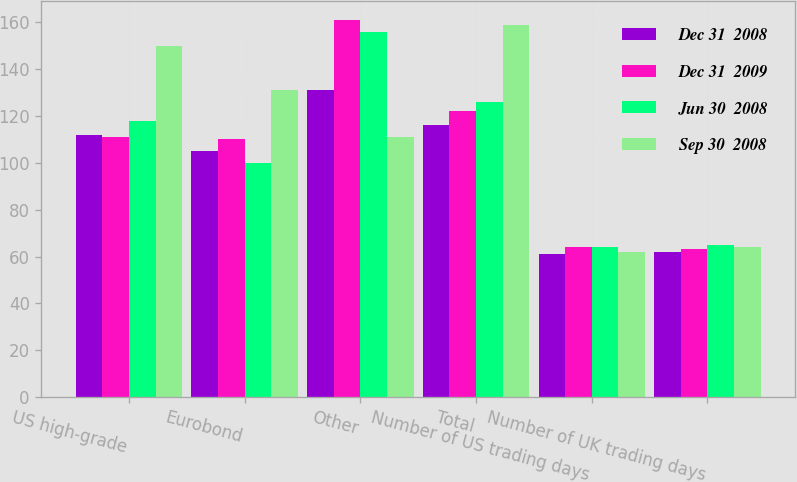Convert chart. <chart><loc_0><loc_0><loc_500><loc_500><stacked_bar_chart><ecel><fcel>US high-grade<fcel>Eurobond<fcel>Other<fcel>Total<fcel>Number of US trading days<fcel>Number of UK trading days<nl><fcel>Dec 31  2008<fcel>112<fcel>105<fcel>131<fcel>116<fcel>61<fcel>62<nl><fcel>Dec 31  2009<fcel>111<fcel>110<fcel>161<fcel>122<fcel>64<fcel>63<nl><fcel>Jun 30  2008<fcel>118<fcel>100<fcel>156<fcel>126<fcel>64<fcel>65<nl><fcel>Sep 30  2008<fcel>150<fcel>131<fcel>111<fcel>159<fcel>62<fcel>64<nl></chart> 